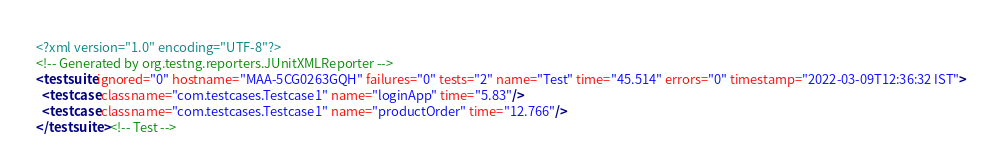Convert code to text. <code><loc_0><loc_0><loc_500><loc_500><_XML_><?xml version="1.0" encoding="UTF-8"?>
<!-- Generated by org.testng.reporters.JUnitXMLReporter -->
<testsuite ignored="0" hostname="MAA-5CG0263GQH" failures="0" tests="2" name="Test" time="45.514" errors="0" timestamp="2022-03-09T12:36:32 IST">
  <testcase classname="com.testcases.Testcase1" name="loginApp" time="5.83"/>
  <testcase classname="com.testcases.Testcase1" name="productOrder" time="12.766"/>
</testsuite> <!-- Test -->
</code> 